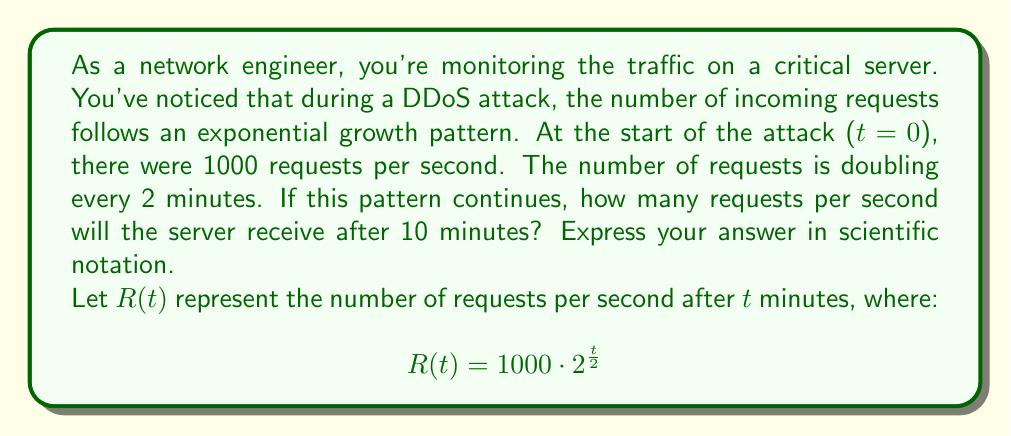Give your solution to this math problem. To solve this problem, we'll follow these steps:

1) We're given the exponential function:
   $$ R(t) = 1000 \cdot 2^{\frac{t}{2}} $$

2) We need to find R(10), as we want to know the number of requests after 10 minutes:
   $$ R(10) = 1000 \cdot 2^{\frac{10}{2}} $$

3) Simplify the exponent:
   $$ R(10) = 1000 \cdot 2^5 $$

4) Calculate $2^5$:
   $$ R(10) = 1000 \cdot 32 $$

5) Multiply:
   $$ R(10) = 32,000 $$

6) Convert to scientific notation:
   $$ R(10) = 3.2 \times 10^4 $$

Therefore, after 10 minutes, the server will receive 32,000 requests per second, or $3.2 \times 10^4$ in scientific notation.
Answer: $3.2 \times 10^4$ requests per second 